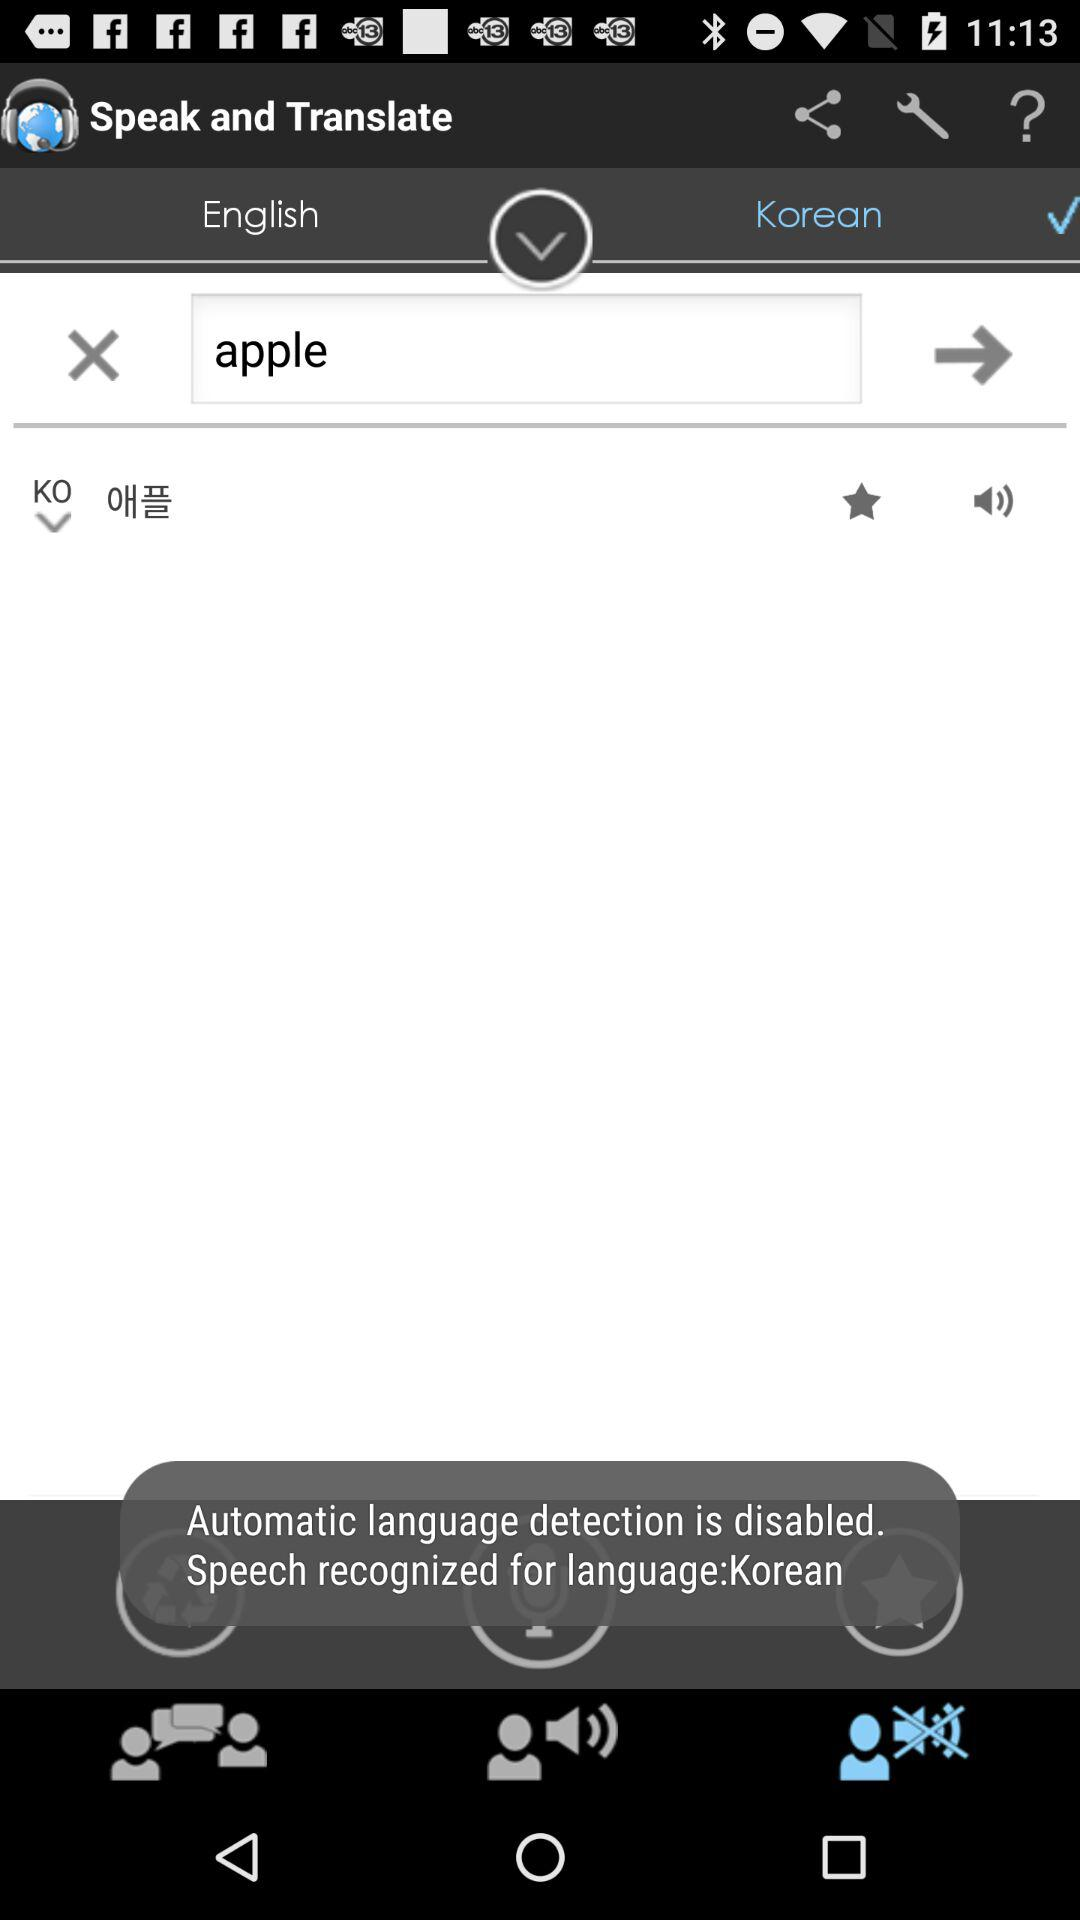For which word does the person want the translation? The word is "apple". 